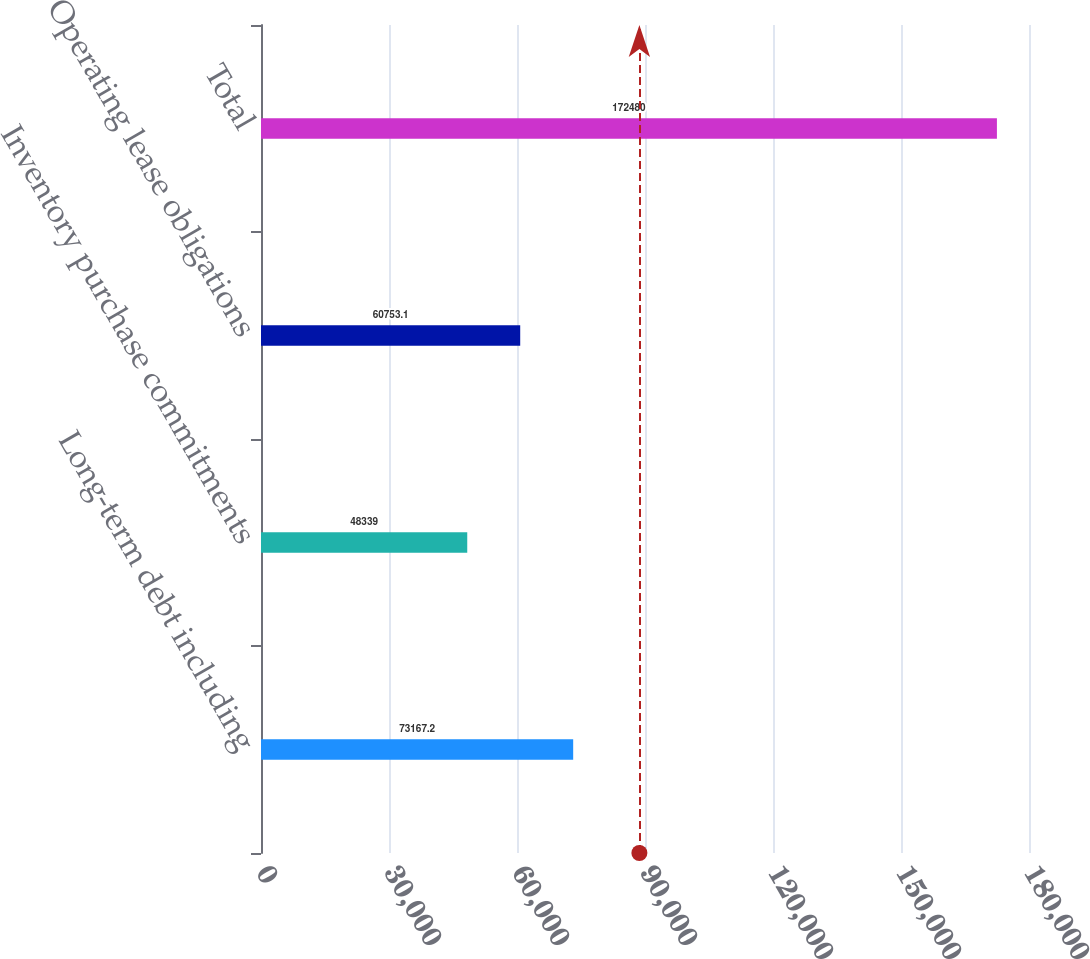Convert chart. <chart><loc_0><loc_0><loc_500><loc_500><bar_chart><fcel>Long-term debt including<fcel>Inventory purchase commitments<fcel>Operating lease obligations<fcel>Total<nl><fcel>73167.2<fcel>48339<fcel>60753.1<fcel>172480<nl></chart> 